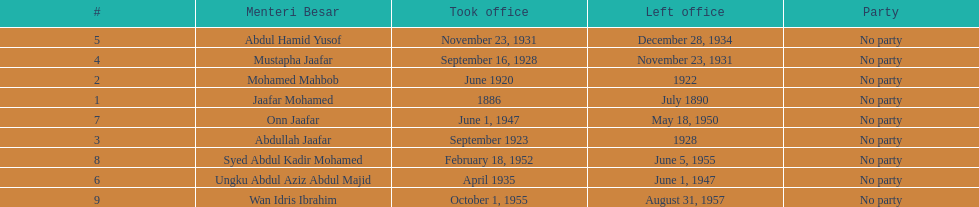Who took office after abdullah jaafar? Mustapha Jaafar. 